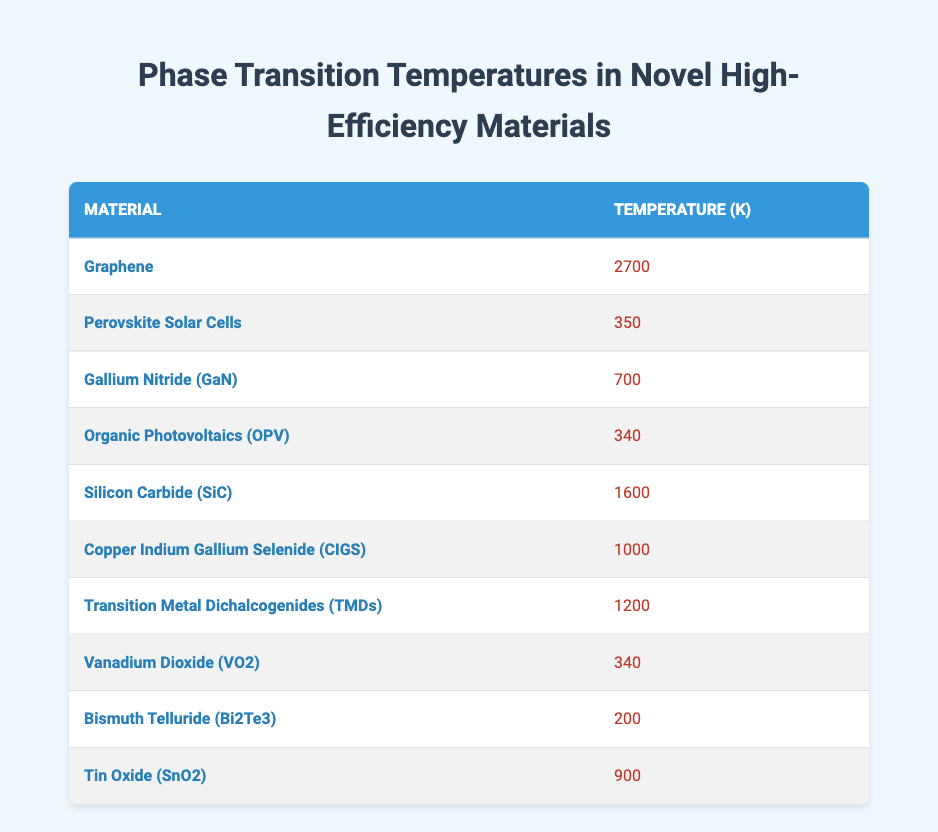What is the phase transition temperature of Copper Indium Gallium Selenide (CIGS)? The table lists the temperature for Copper Indium Gallium Selenide (CIGS) under the Temperature (K) column, which is 1000 K.
Answer: 1000 K Which material has the highest phase transition temperature? By examining the Temperature (K) column, Graphene has the highest temperature listed at 2700 K, more than any other material in the table.
Answer: Graphene How many materials have a phase transition temperature below 500 K? The materials with temperatures below 500 K are Perovskite Solar Cells (350 K), Organic Photovoltaics (OPV) (340 K), Vanadium Dioxide (VO2) (340 K), and Bismuth Telluride (Bi2Te3) (200 K). There are 4 materials that meet this criterion.
Answer: 4 What is the average phase transition temperature of the materials listed? First, we sum all the temperatures: 2700 + 350 + 700 + 340 + 1600 + 1000 + 1200 + 340 + 200 + 900 = 6430 K. Then we divide by the number of materials, which is 10: 6430 K / 10 = 643 K.
Answer: 643 K Is the phase transition temperature of Gallium Nitride (GaN) greater than that of Silicon Carbide (SiC)? Gallium Nitride (GaN) has a temperature of 700 K, while Silicon Carbide (SiC) has a temperature of 1600 K. Since 700 K is not greater than 1600 K, the statement is false.
Answer: No Which materials have the same phase transition temperature of 340 K? The table indicates that both Perovskite Solar Cells and Vanadium Dioxide (VO2) have a phase transition temperature of 340 K.
Answer: Perovskite Solar Cells and Vanadium Dioxide (VO2) What is the difference in phase transition temperatures between Tin Oxide (SnO2) and Bismuth Telluride (Bi2Te3)? The temperature for Tin Oxide (SnO2) is 900 K and for Bismuth Telluride (Bi2Te3) is 200 K. The difference is 900 K - 200 K = 700 K.
Answer: 700 K How many materials have a phase transition temperature greater than 1000 K? The materials with temperatures greater than 1000 K are Graphene (2700 K), Silicon Carbide (1600 K), Transition Metal Dichalcogenides (TMDs) (1200 K), and Copper Indium Gallium Selenide (CIGS) (1000 K). However, CIGS is equal to 1000 K, so we only count the others, totaling 3 materials.
Answer: 3 